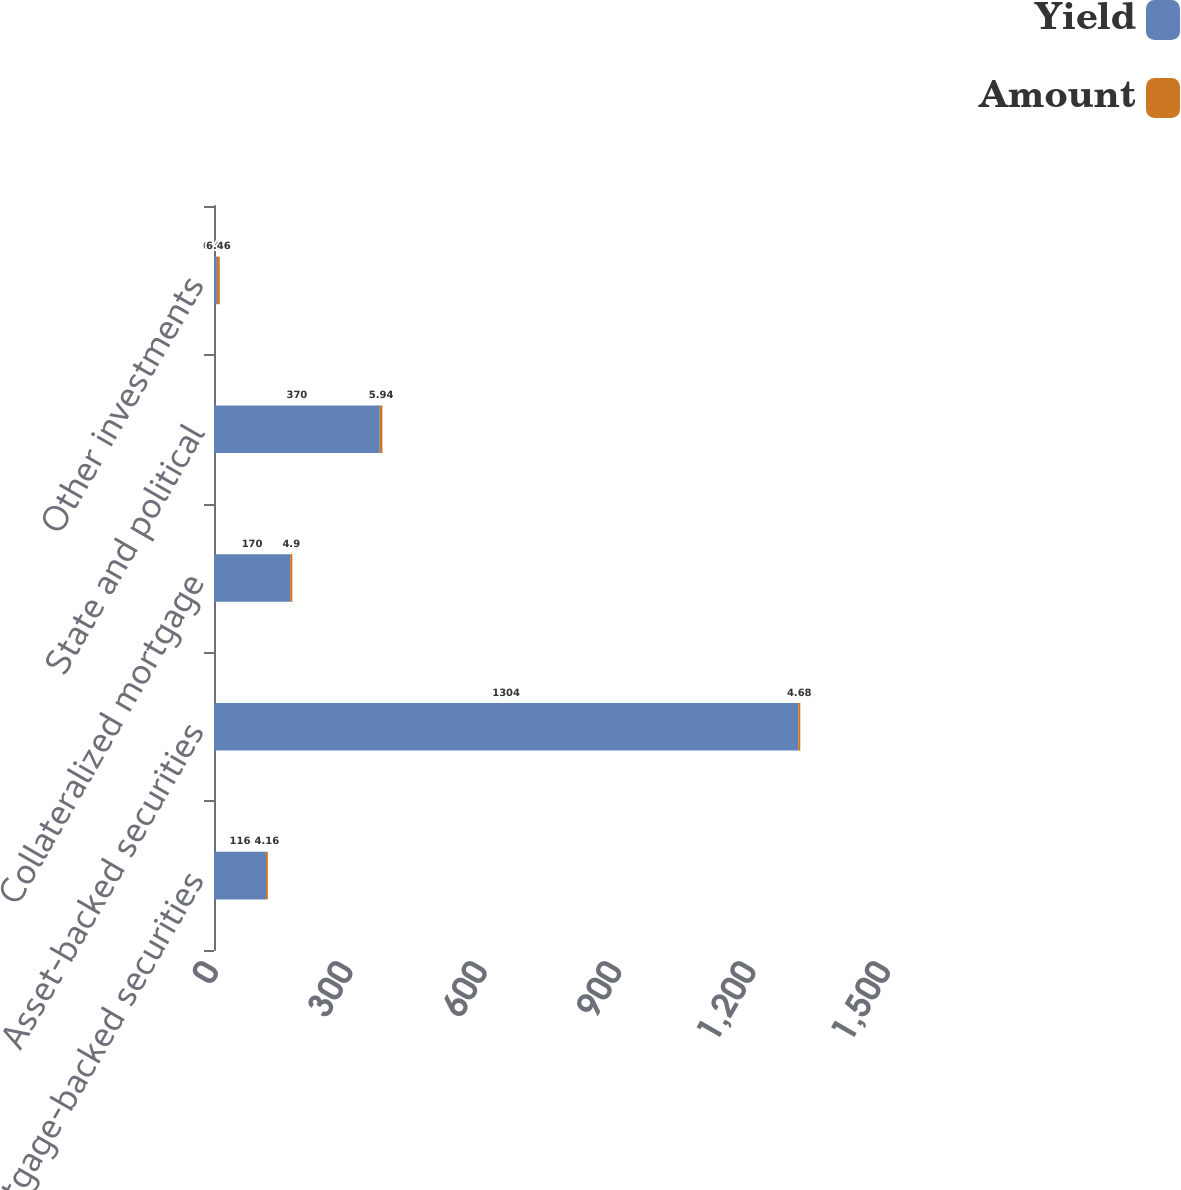Convert chart. <chart><loc_0><loc_0><loc_500><loc_500><stacked_bar_chart><ecel><fcel>Mortgage-backed securities<fcel>Asset-backed securities<fcel>Collateralized mortgage<fcel>State and political<fcel>Other investments<nl><fcel>Yield<fcel>116<fcel>1304<fcel>170<fcel>370<fcel>6.46<nl><fcel>Amount<fcel>4.16<fcel>4.68<fcel>4.9<fcel>5.94<fcel>6.46<nl></chart> 